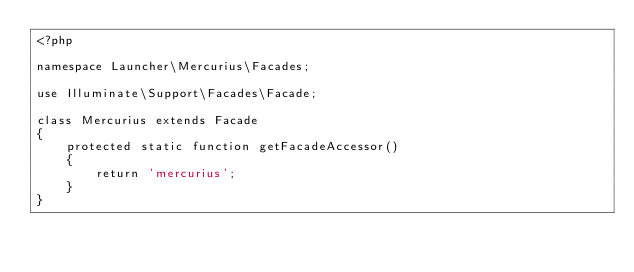<code> <loc_0><loc_0><loc_500><loc_500><_PHP_><?php

namespace Launcher\Mercurius\Facades;

use Illuminate\Support\Facades\Facade;

class Mercurius extends Facade
{
    protected static function getFacadeAccessor()
    {
        return 'mercurius';
    }
}
</code> 